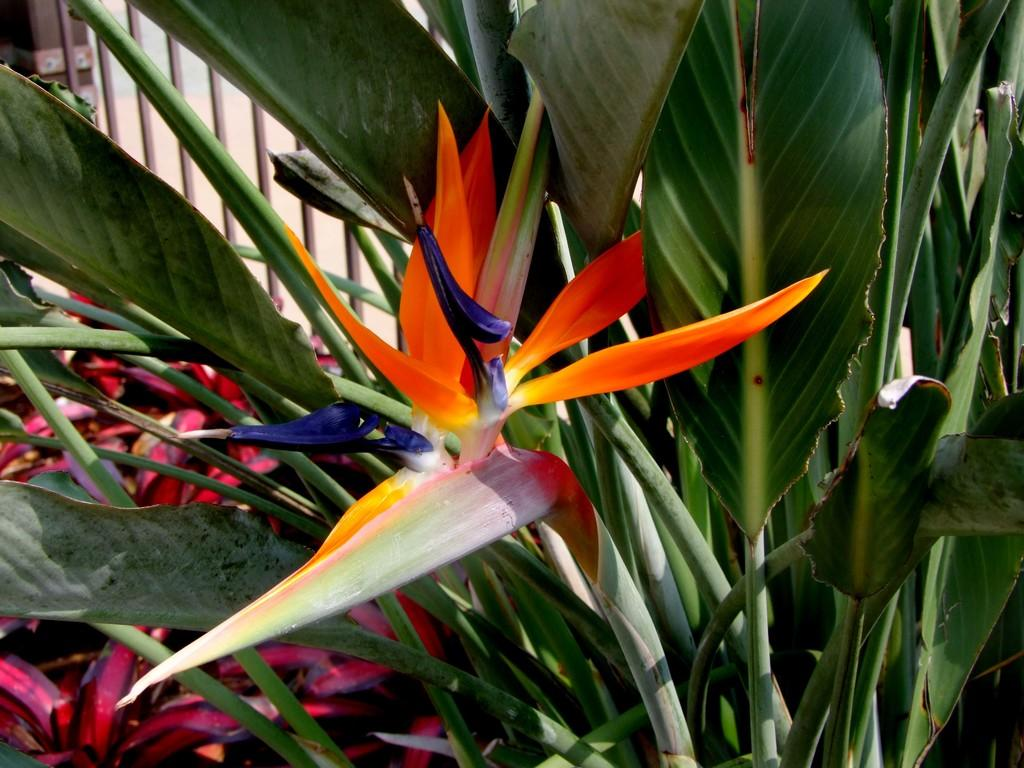What types of living organisms can be seen in the image? Plants and flowers are visible in the image. Can you describe the flowers in the image? The flowers in the image are part of the plants and add color and beauty to the scene. What type of toys can be seen in the image? There are no toys present in the image; it features plants and flowers. What is the level of disgust that can be observed in the image? There is no indication of disgust in the image, as it focuses on plants and flowers. 